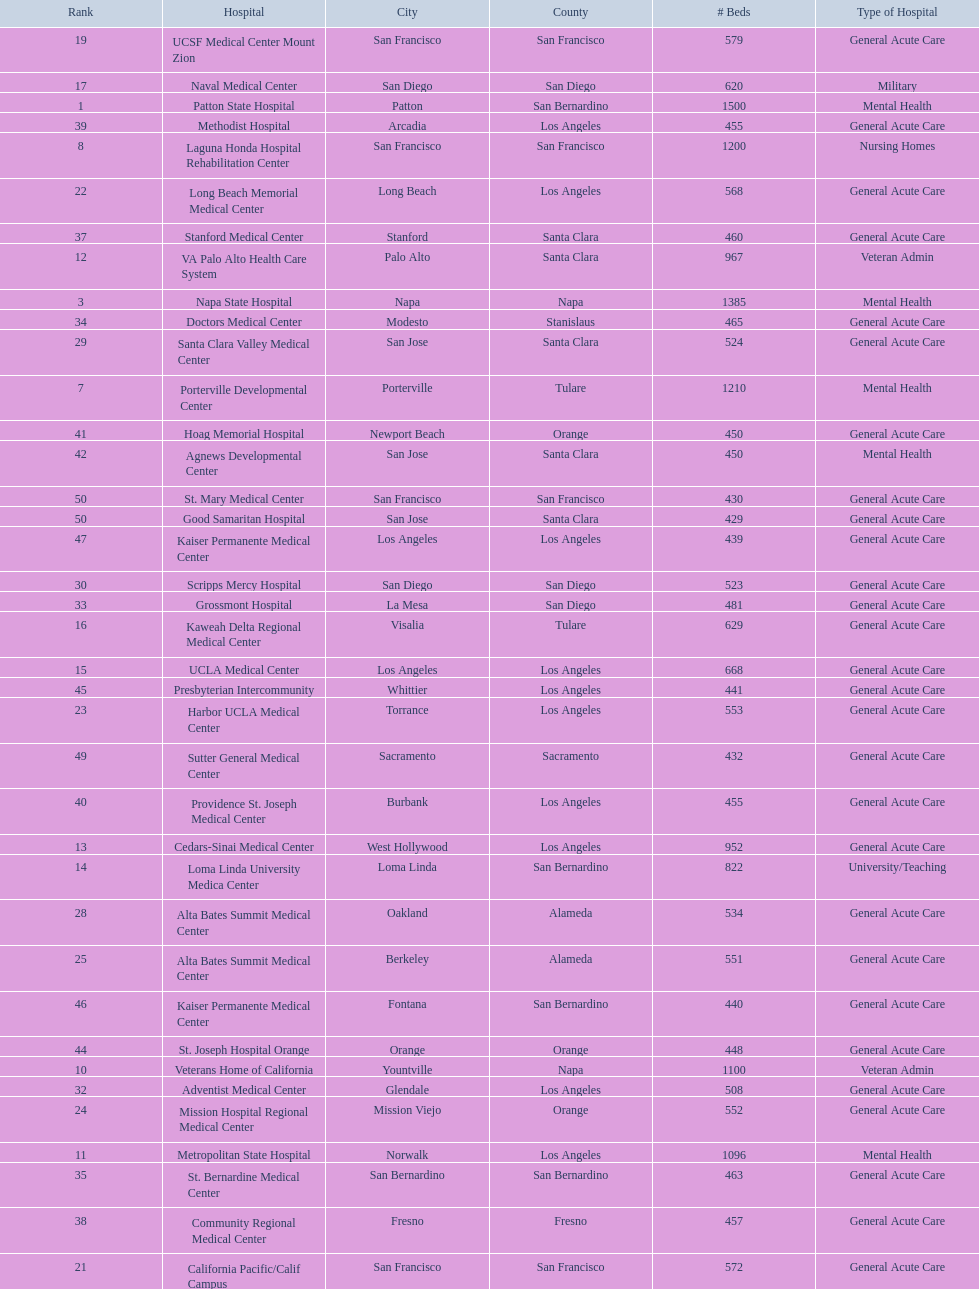Does patton state hospital in the city of patton in san bernardino county have more mental health hospital beds than atascadero state hospital in atascadero, san luis obispo county? Yes. 